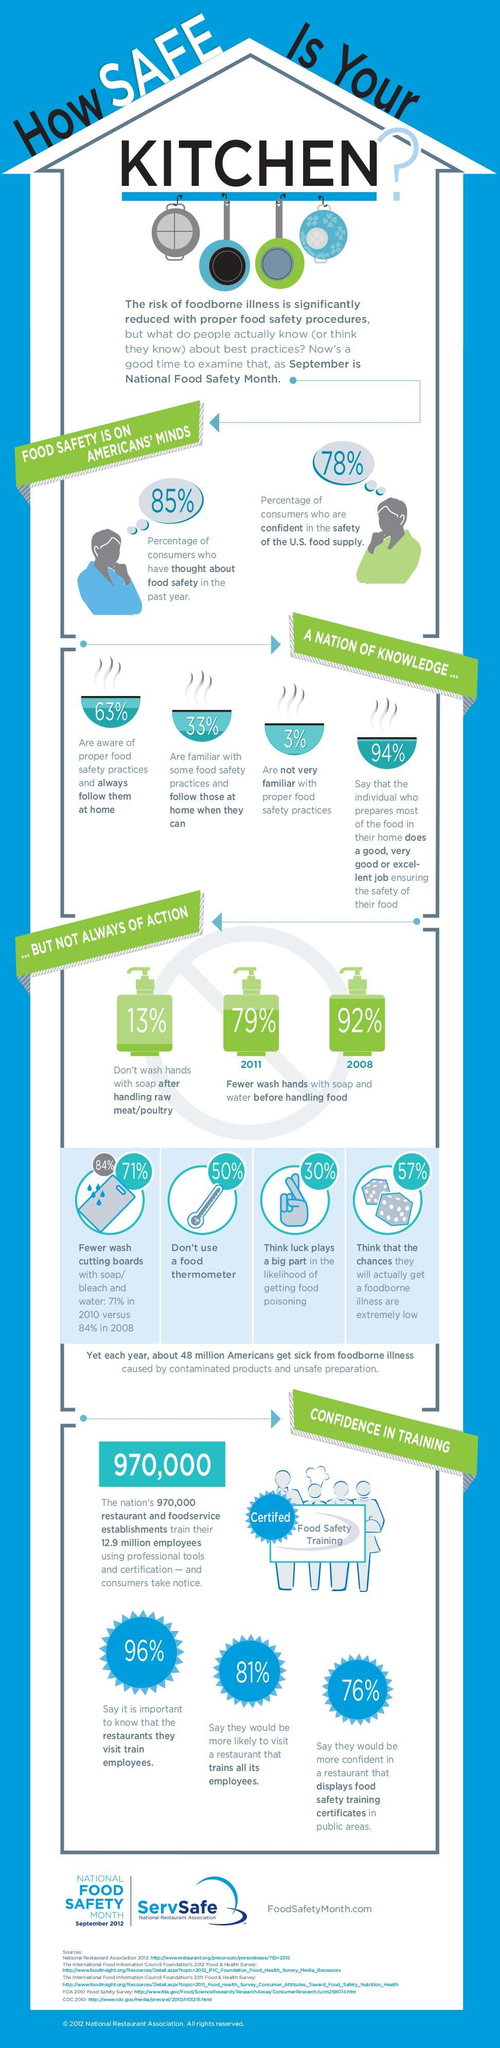What percent of Americans practise only a few hand washes before handling the food in 2008?
Answer the question with a short phrase. 92% What percent of Americans are familiar with proper food safety practices? 97% What percent of Americans don't use a food thermometer? 50% What percent of Americans wash hands with soap after handling raw or poultry? 87% What percentage of Americans think that the chance of getting a food borne illness is extremely low? 57% 